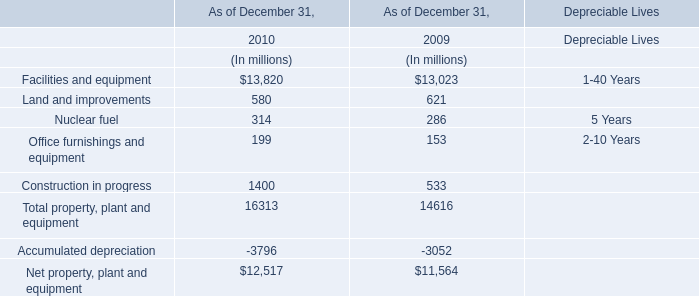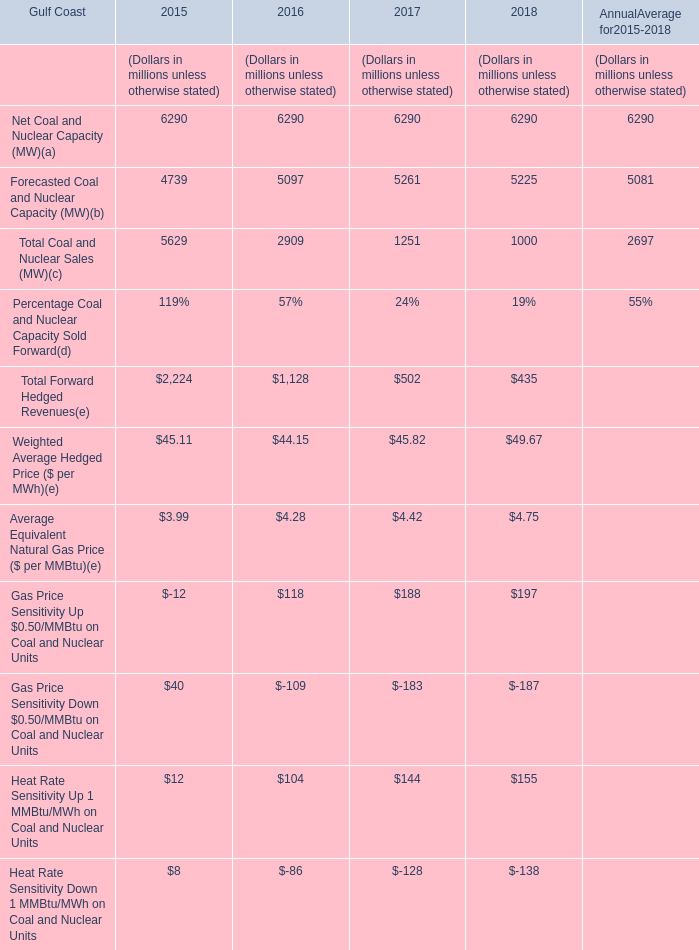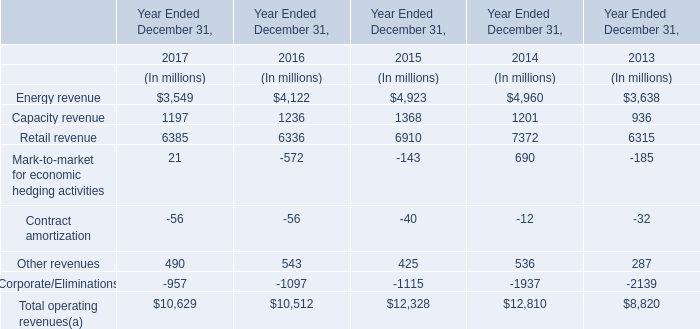What's the total amount of the Weighted Average Hedged Price ($ per MWh)(e) in the years where Capacity revenue is greater than 1230? (in million) 
Computations: (45.11 + 44.15)
Answer: 89.26. 